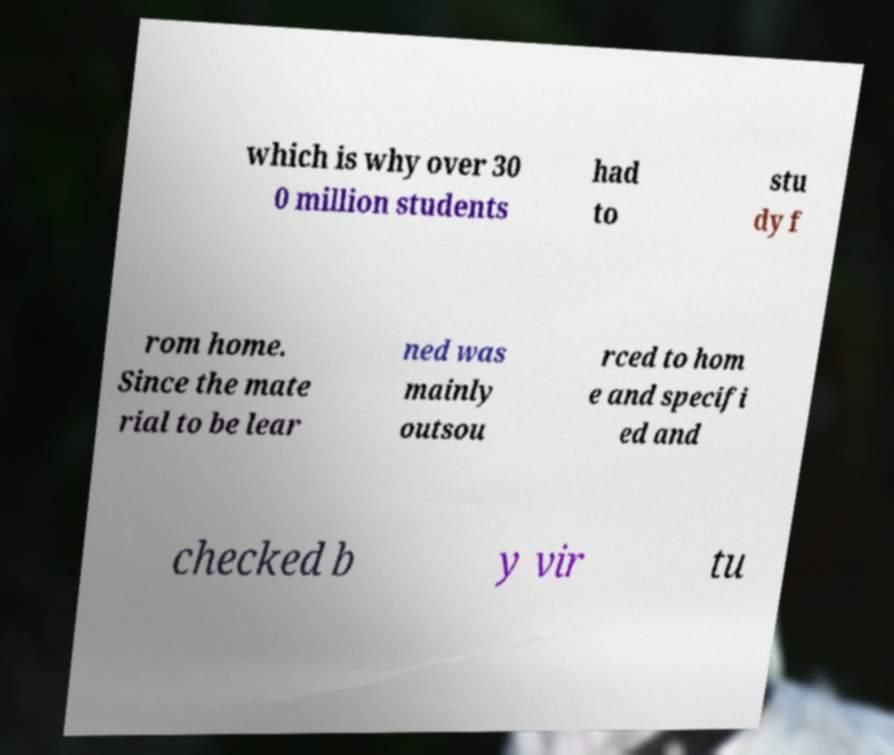Could you extract and type out the text from this image? which is why over 30 0 million students had to stu dy f rom home. Since the mate rial to be lear ned was mainly outsou rced to hom e and specifi ed and checked b y vir tu 